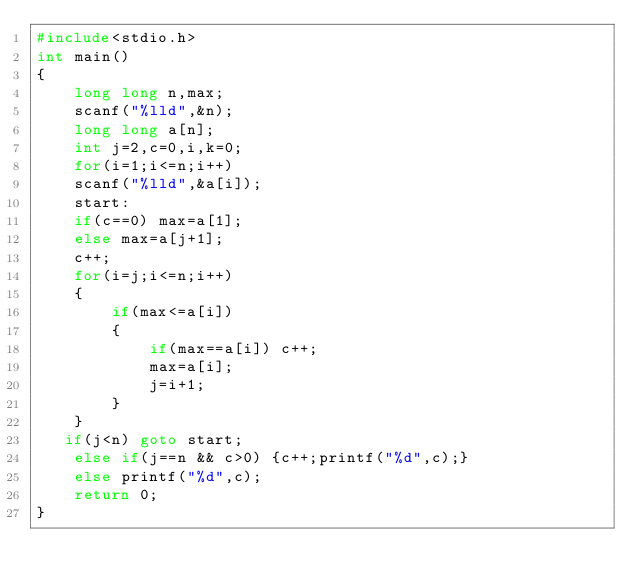<code> <loc_0><loc_0><loc_500><loc_500><_C_>#include<stdio.h>
int main()
{
    long long n,max;
    scanf("%lld",&n);
    long long a[n];
    int j=2,c=0,i,k=0;
    for(i=1;i<=n;i++)
    scanf("%lld",&a[i]);
    start:
    if(c==0) max=a[1];
    else max=a[j+1];
    c++;
    for(i=j;i<=n;i++)
    {
        if(max<=a[i])
        {
            if(max==a[i]) c++;
            max=a[i];
            j=i+1;
        }
    }
   if(j<n) goto start;
    else if(j==n && c>0) {c++;printf("%d",c);}
    else printf("%d",c);
    return 0;
}
</code> 